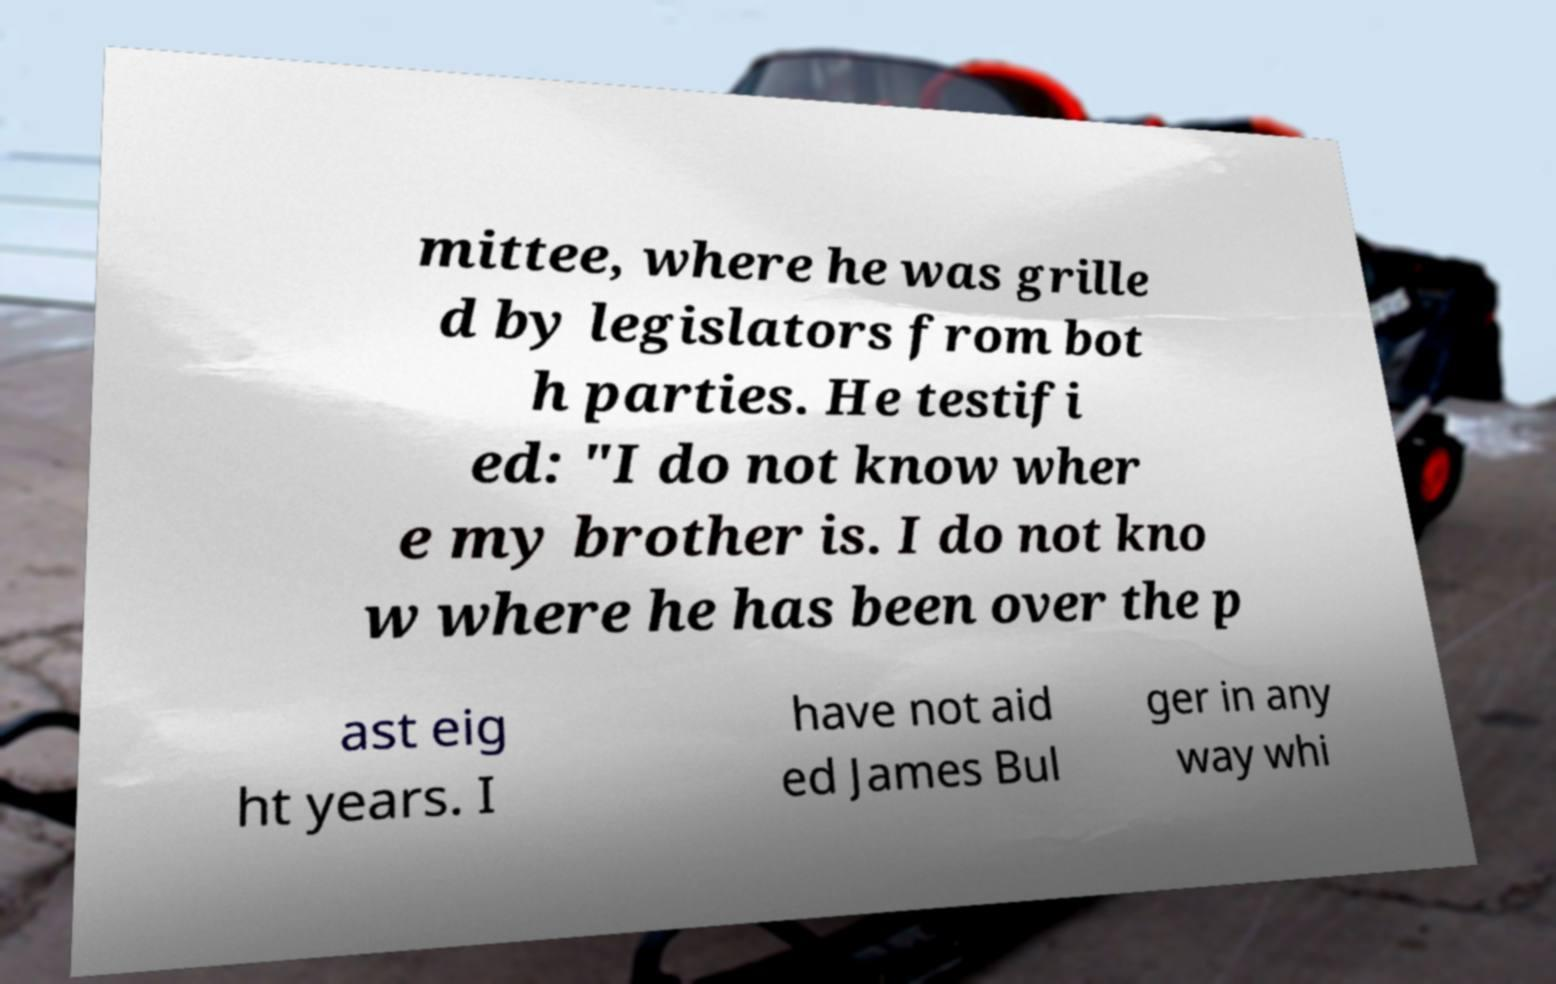Can you accurately transcribe the text from the provided image for me? mittee, where he was grille d by legislators from bot h parties. He testifi ed: "I do not know wher e my brother is. I do not kno w where he has been over the p ast eig ht years. I have not aid ed James Bul ger in any way whi 